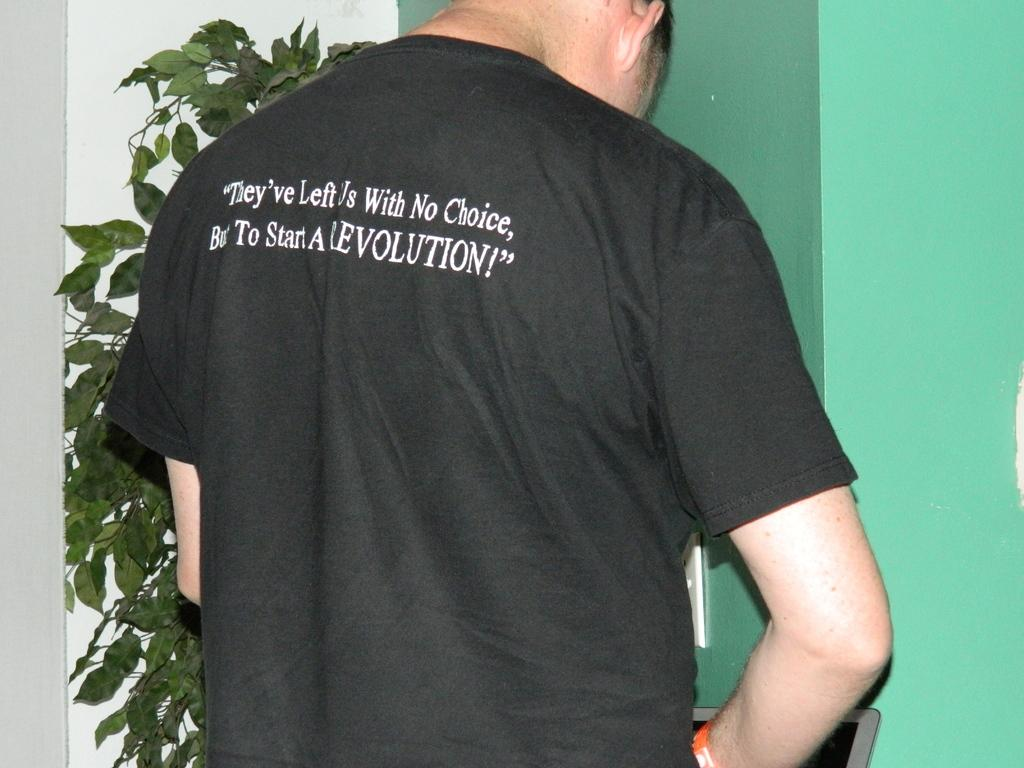Provide a one-sentence caption for the provided image. A man who appears to be stading at a urinal wearing a black t-shirt espousing his only choice being to start a revolution. 